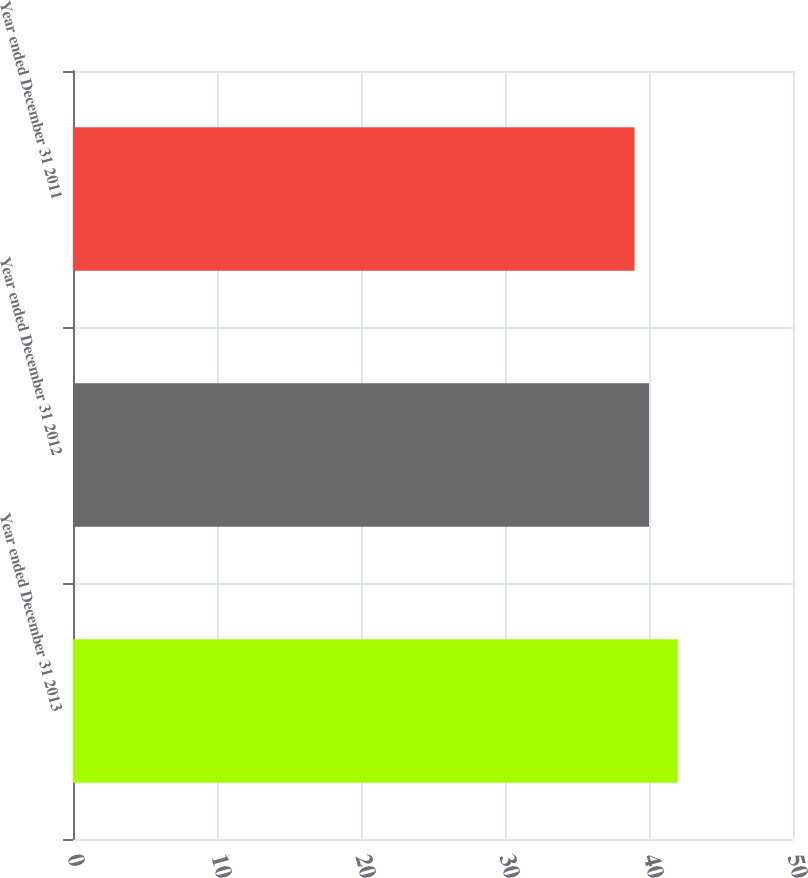Convert chart. <chart><loc_0><loc_0><loc_500><loc_500><bar_chart><fcel>Year ended December 31 2013<fcel>Year ended December 31 2012<fcel>Year ended December 31 2011<nl><fcel>42<fcel>40<fcel>39<nl></chart> 